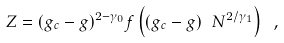<formula> <loc_0><loc_0><loc_500><loc_500>Z = ( g _ { c } - g ) ^ { 2 - \gamma _ { 0 } } f \left ( ( g _ { c } - g ) \ N ^ { 2 / \gamma _ { 1 } } \right ) \ ,</formula> 